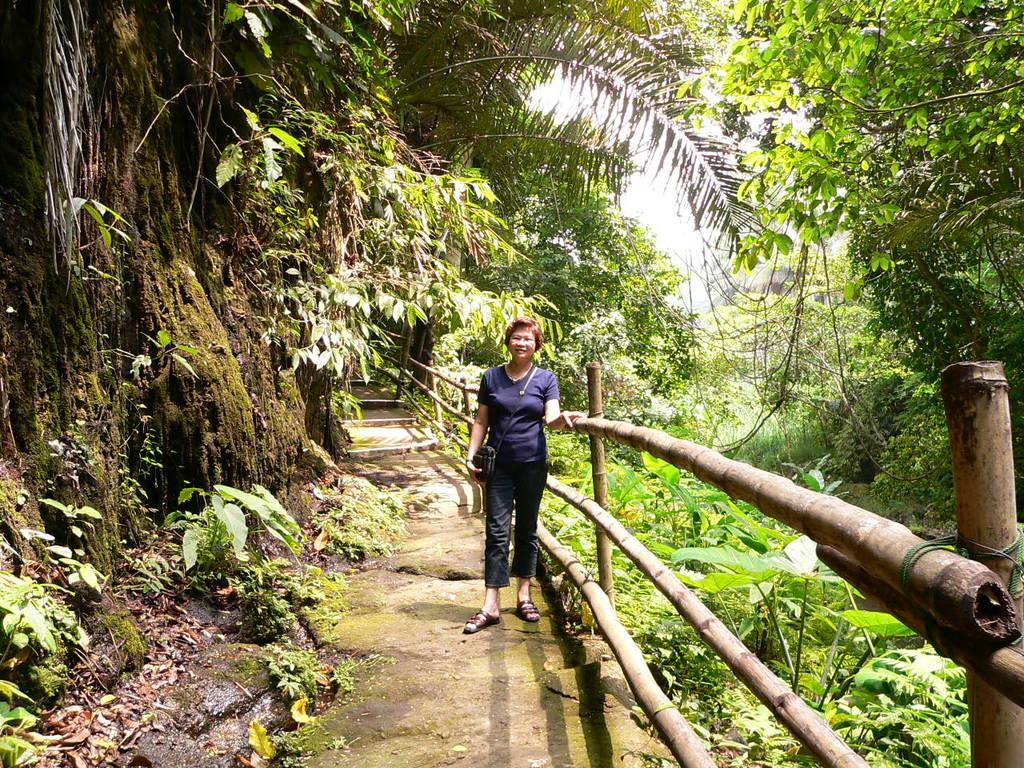How would you summarize this image in a sentence or two? In this image, we can see a person and the fence. We can see the ground. We can see some grass, plants and trees. We can also see the sky. 